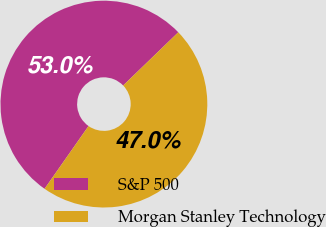<chart> <loc_0><loc_0><loc_500><loc_500><pie_chart><fcel>S&P 500<fcel>Morgan Stanley Technology<nl><fcel>53.05%<fcel>46.95%<nl></chart> 